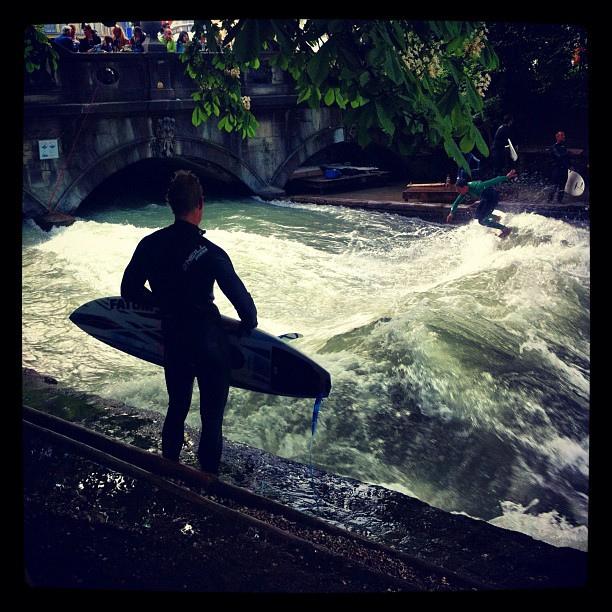Is there a surfboard?
Be succinct. Yes. Is this a natural formation?
Be succinct. No. Is it day or night?
Quick response, please. Day. Is this a smooth or bumpy surface?
Short answer required. Bumpy. 